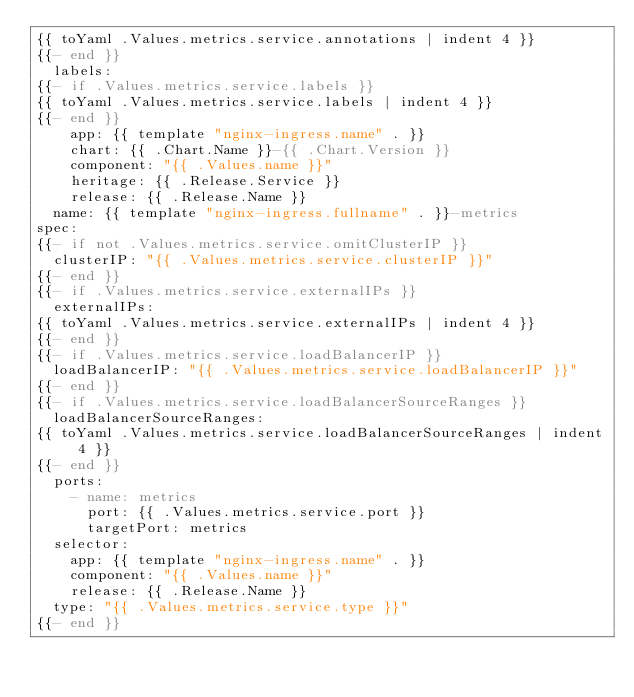Convert code to text. <code><loc_0><loc_0><loc_500><loc_500><_YAML_>{{ toYaml .Values.metrics.service.annotations | indent 4 }}
{{- end }}
  labels:
{{- if .Values.metrics.service.labels }}
{{ toYaml .Values.metrics.service.labels | indent 4 }}
{{- end }}
    app: {{ template "nginx-ingress.name" . }}
    chart: {{ .Chart.Name }}-{{ .Chart.Version }}
    component: "{{ .Values.name }}"
    heritage: {{ .Release.Service }}
    release: {{ .Release.Name }}
  name: {{ template "nginx-ingress.fullname" . }}-metrics
spec:
{{- if not .Values.metrics.service.omitClusterIP }}
  clusterIP: "{{ .Values.metrics.service.clusterIP }}"
{{- end }}
{{- if .Values.metrics.service.externalIPs }}
  externalIPs:
{{ toYaml .Values.metrics.service.externalIPs | indent 4 }}
{{- end }}
{{- if .Values.metrics.service.loadBalancerIP }}
  loadBalancerIP: "{{ .Values.metrics.service.loadBalancerIP }}"
{{- end }}
{{- if .Values.metrics.service.loadBalancerSourceRanges }}
  loadBalancerSourceRanges:
{{ toYaml .Values.metrics.service.loadBalancerSourceRanges | indent 4 }}
{{- end }}
  ports:
    - name: metrics
      port: {{ .Values.metrics.service.port }}
      targetPort: metrics
  selector:
    app: {{ template "nginx-ingress.name" . }}
    component: "{{ .Values.name }}"
    release: {{ .Release.Name }}
  type: "{{ .Values.metrics.service.type }}"
{{- end }}
</code> 